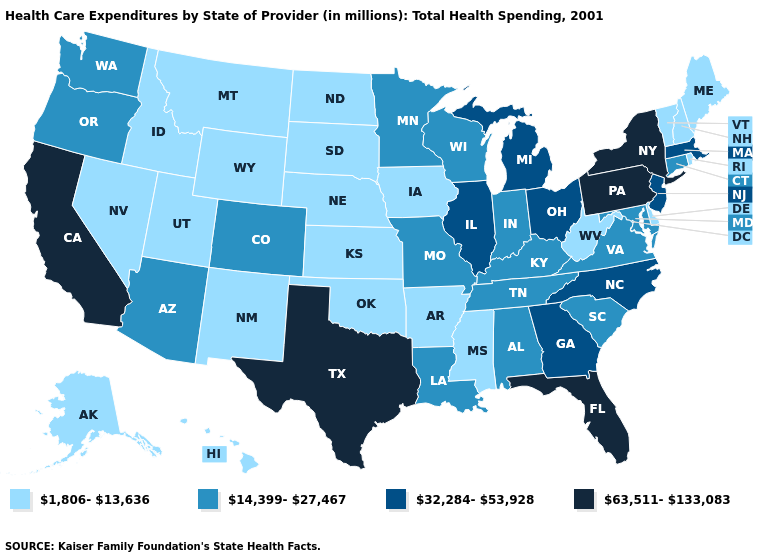Does Michigan have a lower value than Delaware?
Be succinct. No. What is the value of New Hampshire?
Short answer required. 1,806-13,636. Name the states that have a value in the range 14,399-27,467?
Keep it brief. Alabama, Arizona, Colorado, Connecticut, Indiana, Kentucky, Louisiana, Maryland, Minnesota, Missouri, Oregon, South Carolina, Tennessee, Virginia, Washington, Wisconsin. Name the states that have a value in the range 32,284-53,928?
Be succinct. Georgia, Illinois, Massachusetts, Michigan, New Jersey, North Carolina, Ohio. What is the value of Idaho?
Quick response, please. 1,806-13,636. What is the highest value in the USA?
Be succinct. 63,511-133,083. How many symbols are there in the legend?
Be succinct. 4. Among the states that border Iowa , which have the lowest value?
Write a very short answer. Nebraska, South Dakota. What is the value of New York?
Give a very brief answer. 63,511-133,083. Does California have the highest value in the West?
Keep it brief. Yes. What is the value of Hawaii?
Answer briefly. 1,806-13,636. What is the lowest value in the MidWest?
Concise answer only. 1,806-13,636. How many symbols are there in the legend?
Short answer required. 4. What is the value of Utah?
Be succinct. 1,806-13,636. 